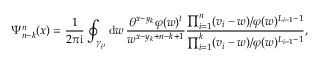<formula> <loc_0><loc_0><loc_500><loc_500>\Psi _ { n - k } ^ { n } ( x ) = \frac { 1 } { 2 \pi i } \oint _ { \gamma _ { \rho } } d w \, \frac { \theta ^ { x - y _ { k } } \varphi ( w ) ^ { t } } { w ^ { x - y _ { k } + n - k + 1 } } \frac { \prod _ { i = 1 } ^ { n } ( v _ { i } - w ) / \varphi ( w ) ^ { L _ { i - 1 } - 1 } } { \prod _ { i = 1 } ^ { k } ( v _ { i } - w ) / \varphi ( w ) ^ { L _ { i - 1 } - 1 } } ,</formula> 